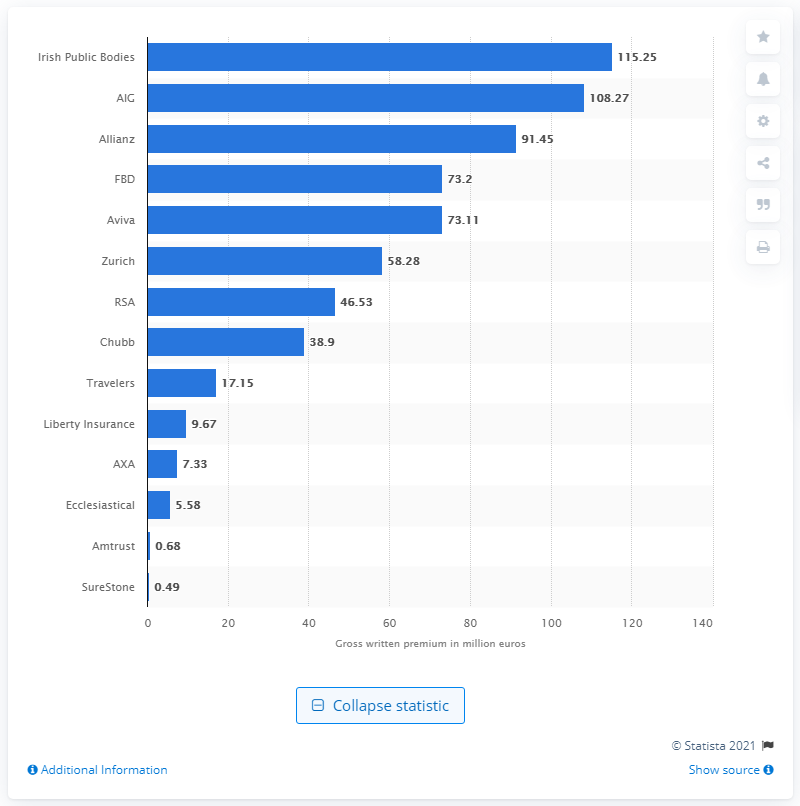Point out several critical features in this image. The total gross written premium for the liability insurance sector in Ireland in 2018 was 115.25. 